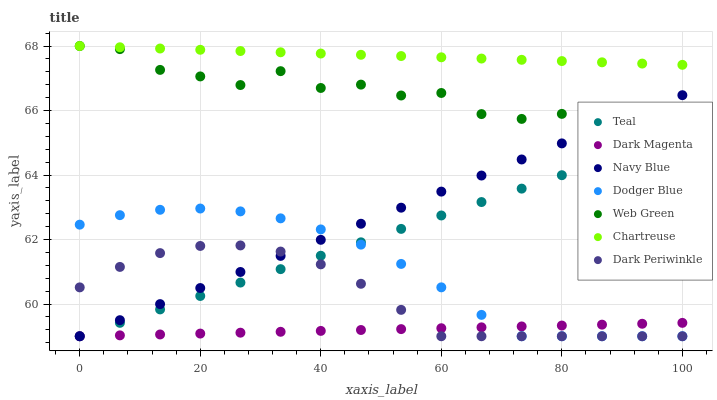Does Dark Magenta have the minimum area under the curve?
Answer yes or no. Yes. Does Chartreuse have the maximum area under the curve?
Answer yes or no. Yes. Does Navy Blue have the minimum area under the curve?
Answer yes or no. No. Does Navy Blue have the maximum area under the curve?
Answer yes or no. No. Is Teal the smoothest?
Answer yes or no. Yes. Is Web Green the roughest?
Answer yes or no. Yes. Is Navy Blue the smoothest?
Answer yes or no. No. Is Navy Blue the roughest?
Answer yes or no. No. Does Dark Magenta have the lowest value?
Answer yes or no. Yes. Does Web Green have the lowest value?
Answer yes or no. No. Does Chartreuse have the highest value?
Answer yes or no. Yes. Does Navy Blue have the highest value?
Answer yes or no. No. Is Teal less than Chartreuse?
Answer yes or no. Yes. Is Chartreuse greater than Dodger Blue?
Answer yes or no. Yes. Does Navy Blue intersect Dark Magenta?
Answer yes or no. Yes. Is Navy Blue less than Dark Magenta?
Answer yes or no. No. Is Navy Blue greater than Dark Magenta?
Answer yes or no. No. Does Teal intersect Chartreuse?
Answer yes or no. No. 